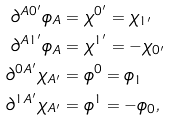<formula> <loc_0><loc_0><loc_500><loc_500>\partial ^ { A 0 ^ { \prime } } \phi _ { A } & = \chi ^ { 0 ^ { \prime } } = \chi _ { 1 ^ { \prime } } \\ \partial ^ { A 1 ^ { \prime } } \phi _ { A } & = \chi ^ { 1 ^ { \prime } } = - \chi _ { 0 ^ { \prime } } \\ \partial ^ { 0 A ^ { \prime } } \chi _ { A ^ { \prime } } & = \phi ^ { 0 } = \phi _ { 1 } \\ \partial ^ { 1 A ^ { \prime } } \chi _ { A ^ { \prime } } & = \phi ^ { 1 } = - \phi _ { 0 } ,</formula> 